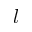<formula> <loc_0><loc_0><loc_500><loc_500>l</formula> 